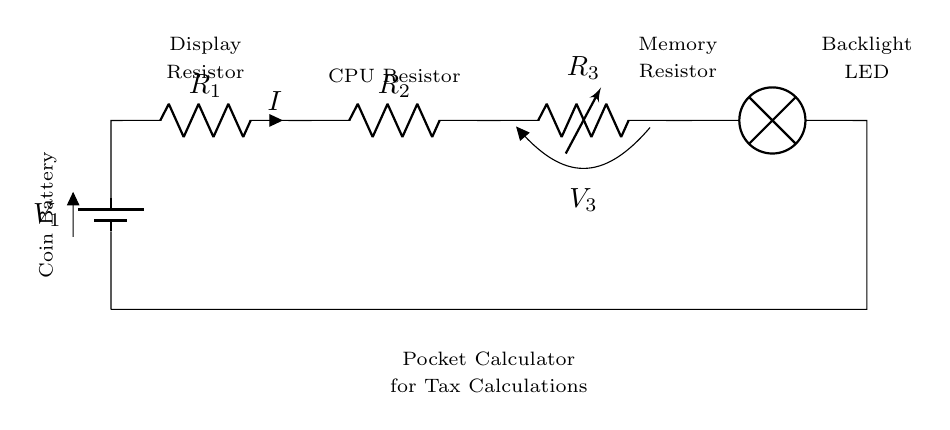What is the power source in this circuit? The circuit's power source is denoted as a battery labeled V1. This indicates that it provides the necessary electrical energy to operate the circuit.
Answer: battery What type of circuit is this? The circuit is a series circuit, meaning that all components are connected in a single path, allowing current to flow through each part sequentially.
Answer: series circuit How many resistors are present in the circuit? There are three resistors indicated in the circuit diagram, labeled R1, R2, and R3. Each resistor affects the overall resistance and current in the series.
Answer: three What is being powered by this circuit? The pocket calculator, labeled in the diagram, is the device being powered by this circuit. It indicates that the circuit is tailored for use in tax calculations.
Answer: pocket calculator What is the purpose of the backlight LED in the circuit? The backlight LED provides illumination for the display of the pocket calculator, enhancing visibility, especially in low-light conditions.
Answer: illumination What is the role of the component labeled R3? The component labeled R3 acts as a memory resistor, which means it is used to store or manage electrical energy for the memory functions of the calculator.
Answer: memory resistor 